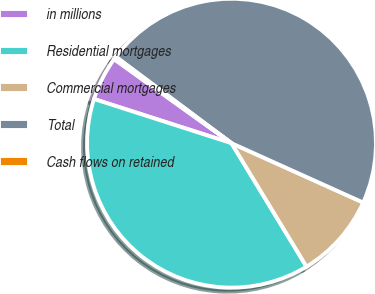Convert chart to OTSL. <chart><loc_0><loc_0><loc_500><loc_500><pie_chart><fcel>in millions<fcel>Residential mortgages<fcel>Commercial mortgages<fcel>Total<fcel>Cash flows on retained<nl><fcel>4.94%<fcel>38.63%<fcel>9.57%<fcel>46.53%<fcel>0.32%<nl></chart> 